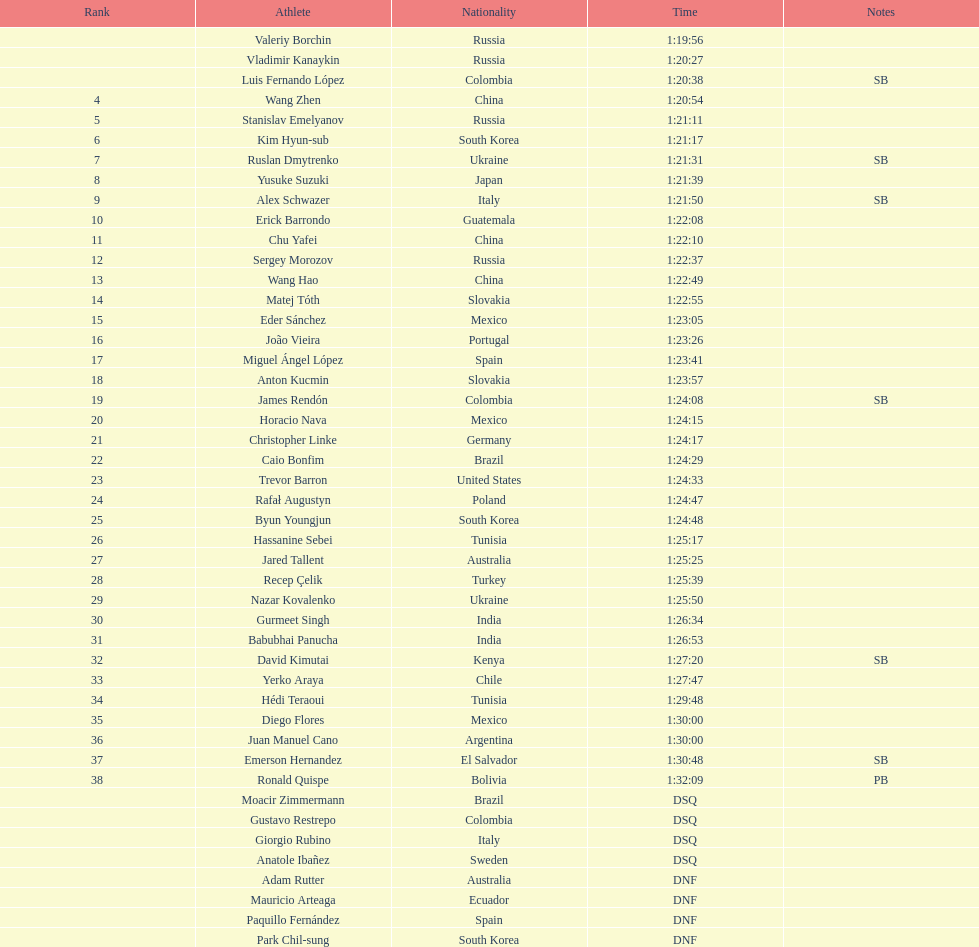Who achieved the number one position? Valeriy Borchin. 